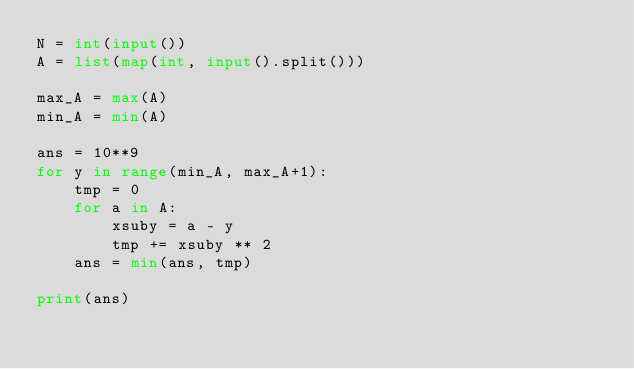<code> <loc_0><loc_0><loc_500><loc_500><_Python_>N = int(input())
A = list(map(int, input().split()))

max_A = max(A)
min_A = min(A)

ans = 10**9
for y in range(min_A, max_A+1):
    tmp = 0
    for a in A:
        xsuby = a - y
        tmp += xsuby ** 2
    ans = min(ans, tmp)

print(ans)
</code> 